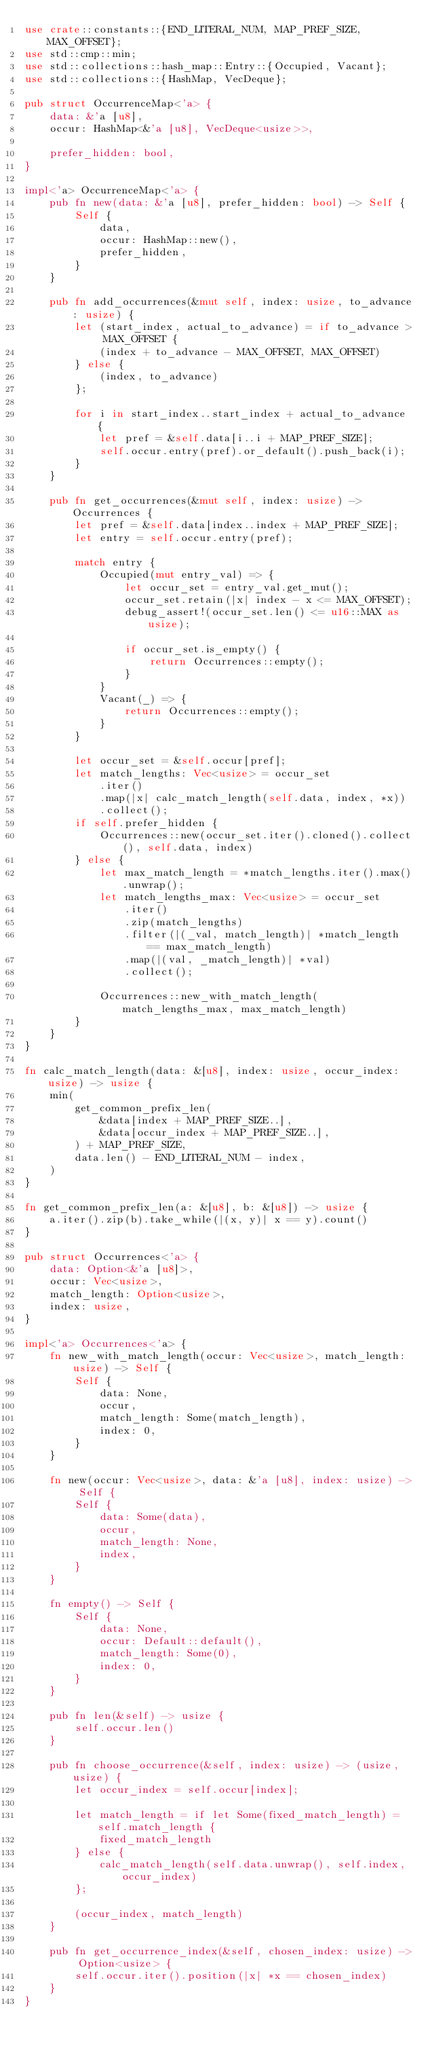<code> <loc_0><loc_0><loc_500><loc_500><_Rust_>use crate::constants::{END_LITERAL_NUM, MAP_PREF_SIZE, MAX_OFFSET};
use std::cmp::min;
use std::collections::hash_map::Entry::{Occupied, Vacant};
use std::collections::{HashMap, VecDeque};

pub struct OccurrenceMap<'a> {
    data: &'a [u8],
    occur: HashMap<&'a [u8], VecDeque<usize>>,

    prefer_hidden: bool,
}

impl<'a> OccurrenceMap<'a> {
    pub fn new(data: &'a [u8], prefer_hidden: bool) -> Self {
        Self {
            data,
            occur: HashMap::new(),
            prefer_hidden,
        }
    }

    pub fn add_occurrences(&mut self, index: usize, to_advance: usize) {
        let (start_index, actual_to_advance) = if to_advance > MAX_OFFSET {
            (index + to_advance - MAX_OFFSET, MAX_OFFSET)
        } else {
            (index, to_advance)
        };

        for i in start_index..start_index + actual_to_advance {
            let pref = &self.data[i..i + MAP_PREF_SIZE];
            self.occur.entry(pref).or_default().push_back(i);
        }
    }

    pub fn get_occurrences(&mut self, index: usize) -> Occurrences {
        let pref = &self.data[index..index + MAP_PREF_SIZE];
        let entry = self.occur.entry(pref);

        match entry {
            Occupied(mut entry_val) => {
                let occur_set = entry_val.get_mut();
                occur_set.retain(|x| index - x <= MAX_OFFSET);
                debug_assert!(occur_set.len() <= u16::MAX as usize);

                if occur_set.is_empty() {
                    return Occurrences::empty();
                }
            }
            Vacant(_) => {
                return Occurrences::empty();
            }
        }

        let occur_set = &self.occur[pref];
        let match_lengths: Vec<usize> = occur_set
            .iter()
            .map(|x| calc_match_length(self.data, index, *x))
            .collect();
        if self.prefer_hidden {
            Occurrences::new(occur_set.iter().cloned().collect(), self.data, index)
        } else {
            let max_match_length = *match_lengths.iter().max().unwrap();
            let match_lengths_max: Vec<usize> = occur_set
                .iter()
                .zip(match_lengths)
                .filter(|(_val, match_length)| *match_length == max_match_length)
                .map(|(val, _match_length)| *val)
                .collect();

            Occurrences::new_with_match_length(match_lengths_max, max_match_length)
        }
    }
}

fn calc_match_length(data: &[u8], index: usize, occur_index: usize) -> usize {
    min(
        get_common_prefix_len(
            &data[index + MAP_PREF_SIZE..],
            &data[occur_index + MAP_PREF_SIZE..],
        ) + MAP_PREF_SIZE,
        data.len() - END_LITERAL_NUM - index,
    )
}

fn get_common_prefix_len(a: &[u8], b: &[u8]) -> usize {
    a.iter().zip(b).take_while(|(x, y)| x == y).count()
}

pub struct Occurrences<'a> {
    data: Option<&'a [u8]>,
    occur: Vec<usize>,
    match_length: Option<usize>,
    index: usize,
}

impl<'a> Occurrences<'a> {
    fn new_with_match_length(occur: Vec<usize>, match_length: usize) -> Self {
        Self {
            data: None,
            occur,
            match_length: Some(match_length),
            index: 0,
        }
    }

    fn new(occur: Vec<usize>, data: &'a [u8], index: usize) -> Self {
        Self {
            data: Some(data),
            occur,
            match_length: None,
            index,
        }
    }

    fn empty() -> Self {
        Self {
            data: None,
            occur: Default::default(),
            match_length: Some(0),
            index: 0,
        }
    }

    pub fn len(&self) -> usize {
        self.occur.len()
    }

    pub fn choose_occurrence(&self, index: usize) -> (usize, usize) {
        let occur_index = self.occur[index];

        let match_length = if let Some(fixed_match_length) = self.match_length {
            fixed_match_length
        } else {
            calc_match_length(self.data.unwrap(), self.index, occur_index)
        };

        (occur_index, match_length)
    }

    pub fn get_occurrence_index(&self, chosen_index: usize) -> Option<usize> {
        self.occur.iter().position(|x| *x == chosen_index)
    }
}
</code> 